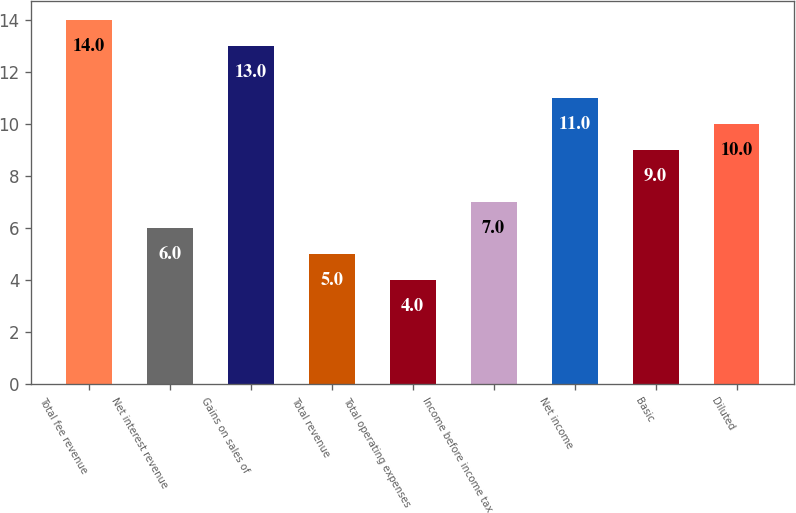Convert chart. <chart><loc_0><loc_0><loc_500><loc_500><bar_chart><fcel>Total fee revenue<fcel>Net interest revenue<fcel>Gains on sales of<fcel>Total revenue<fcel>Total operating expenses<fcel>Income before income tax<fcel>Net income<fcel>Basic<fcel>Diluted<nl><fcel>14<fcel>6<fcel>13<fcel>5<fcel>4<fcel>7<fcel>11<fcel>9<fcel>10<nl></chart> 